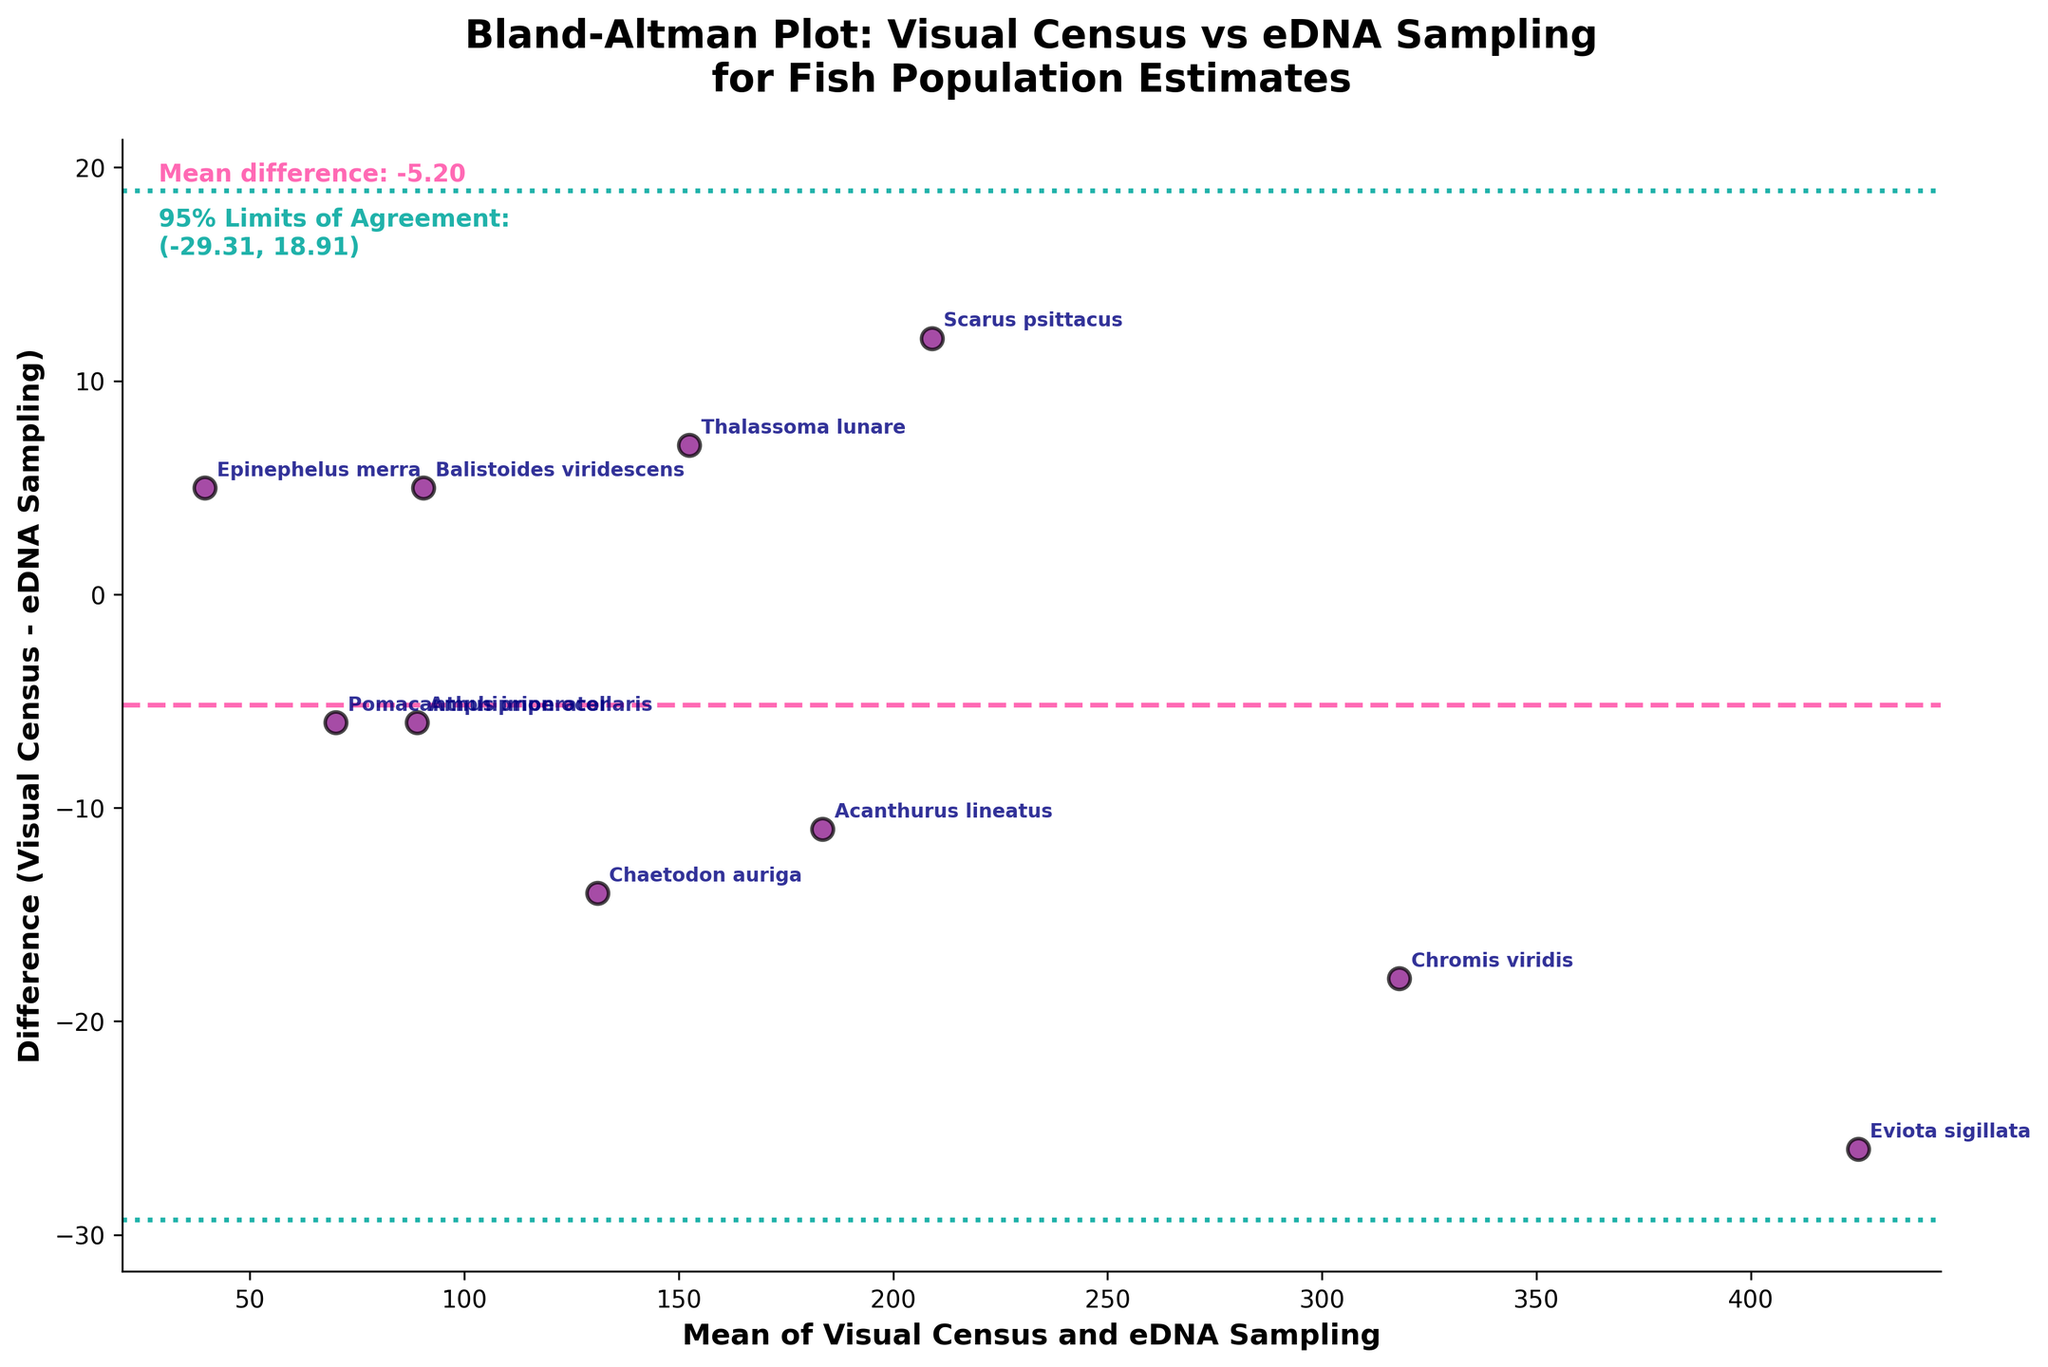What is the title of the plot? Look at the top of the plot to find the title. The title is clearly written and indicates it is a Bland-Altman plot comparing two methods.
Answer: Bland-Altman Plot: Visual Census vs eDNA Sampling for Fish Population Estimates How many fish species are compared in this plot? Count the number of data points annotated with species names on the plot. Each point corresponds to one fish species.
Answer: 10 What is the range of the 95% Limits of Agreement? Locate the text on the plot that specifies the 95% Limits of Agreement. It includes the lower and upper boundaries.
Answer: (-25.83, 27.63) Which species has the largest positive difference between the visual census and eDNA sampling? Look at the points above the zero line and see which has the highest y-value. That species will have the largest positive difference.
Answer: Acanthurus lineatus What's the average of Visual Census and eDNA Sampling counts for Damselfish? Identify the individual counts for Damselfish, sum them up, and then divide by 2. Calculation: (309 + 327) / 2 = 318
Answer: 318 Which species appears closest to the mean difference line? Find the species whose point lies nearest to the dashed mean difference line by visually inspecting the plot.
Answer: Thalassoma lunare What's the mean difference between Visual Census and eDNA Sampling methods for the dataset? Look for the mean difference line on the plot, which usually has a label or text indicating its value.
Answer: 0.90 Is there any species for which the visual census count exactly equals the eDNA sampling count? Check each point on the plot to see if any of them lie exactly on the zero difference line.
Answer: No Which species show a negative difference between the visual census and eDNA sampling methods? Identify the points below the zero difference line and note the species' names.
Answer: Scarus psittacus, Epinephelus merra, Thalassoma lunare, Balistoides viridescens 